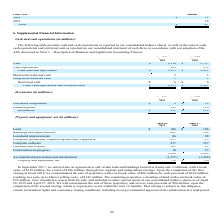From Netapp's financial document, Which years does the table provide information for cash and cash equivalents? The document shows two values: 2019 and 2018. From the document: "2019 2018..." Also, What was the amount of cash in 2019? According to the financial document, 2,216 (in millions). The relevant text states: "Cash $ 2,216 $ 2,727..." Also, What was the amount of cash equivalents in 2018? According to the financial document, 214 (in millions). The relevant text states: "Cash equivalents 109 214..." Also, can you calculate: What was the change in cash between 2018 and 2019? Based on the calculation: 2,216-2,727, the result is -511 (in millions). This is based on the information: "Cash $ 2,216 $ 2,727 Cash $ 2,216 $ 2,727..." The key data points involved are: 2,216, 2,727. Also, can you calculate: What was the change in cash and cash equivalents between 2018 and 2019? Based on the calculation: 2,325-2,941, the result is -616 (in millions). This is based on the information: "Cash and cash equivalents $ 2,325 $ 2,941 Cash and cash equivalents $ 2,325 $ 2,941..." The key data points involved are: 2,325, 2,941. Also, can you calculate: What was the percentage change in Cash, cash equivalents and restricted cash between 2018 and 2019? To answer this question, I need to perform calculations using the financial data. The calculation is: (2,331-2,947)/2,947, which equals -20.9 (percentage). This is based on the information: "h, cash equivalents and restricted cash $ 2,331 $ 2,947 Cash, cash equivalents and restricted cash $ 2,331 $ 2,947..." The key data points involved are: 2,331, 2,947. 